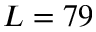Convert formula to latex. <formula><loc_0><loc_0><loc_500><loc_500>L = 7 9</formula> 